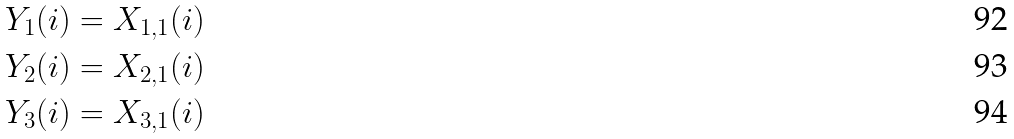Convert formula to latex. <formula><loc_0><loc_0><loc_500><loc_500>Y _ { 1 } ( i ) & = X _ { 1 , 1 } ( i ) \\ Y _ { 2 } ( i ) & = X _ { 2 , 1 } ( i ) \\ Y _ { 3 } ( i ) & = X _ { 3 , 1 } ( i )</formula> 